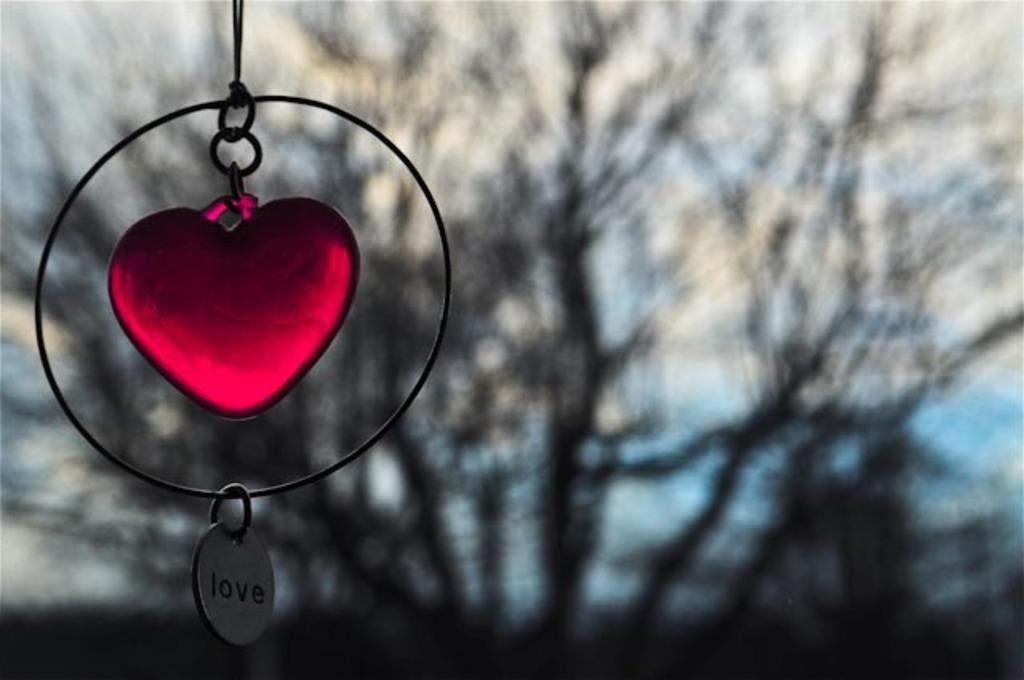What is the color of the object in the image? The object in the image is red and black in color. What can be seen in the background of the image? There are trees in the background of the image. What is the color of the sky in the image? The sky is blue and white in color. What type of songs can be heard coming from the object in the image? There is no indication in the image that the object is producing any sounds, let alone songs. 